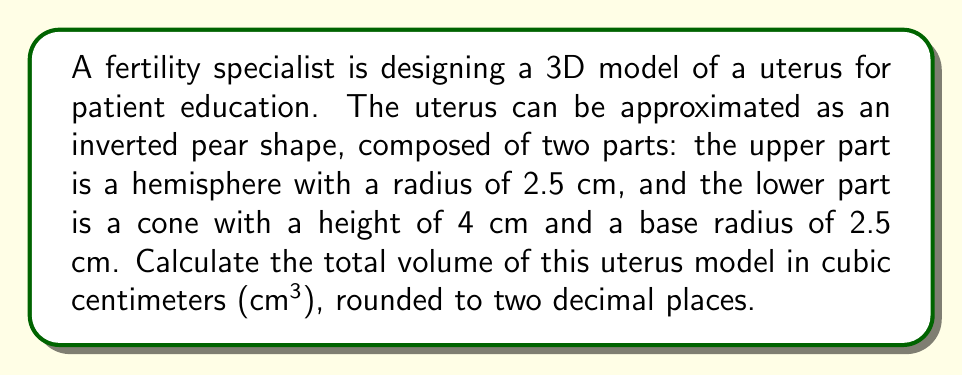Can you solve this math problem? To solve this problem, we need to calculate the volumes of both parts separately and then add them together:

1. Volume of the hemisphere (upper part):
   The volume of a hemisphere is given by the formula:
   $$V_h = \frac{2}{3}\pi r^3$$
   Where $r$ is the radius.
   $$V_h = \frac{2}{3}\pi (2.5\text{ cm})^3 = \frac{2}{3}\pi (15.625\text{ cm}^3) \approx 32.72\text{ cm}^3$$

2. Volume of the cone (lower part):
   The volume of a cone is given by the formula:
   $$V_c = \frac{1}{3}\pi r^2 h$$
   Where $r$ is the base radius and $h$ is the height.
   $$V_c = \frac{1}{3}\pi (2.5\text{ cm})^2 (4\text{ cm}) = \frac{1}{3}\pi (25\text{ cm}^3) \approx 26.18\text{ cm}^3$$

3. Total volume:
   Add the volumes of the hemisphere and cone:
   $$V_{total} = V_h + V_c = 32.72\text{ cm}^3 + 26.18\text{ cm}^3 = 58.90\text{ cm}^3$$

Rounding to two decimal places, we get 58.90 cm³.
Answer: 58.90 cm³ 